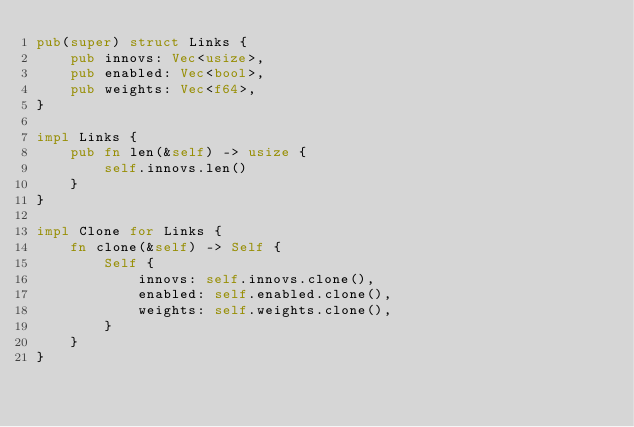<code> <loc_0><loc_0><loc_500><loc_500><_Rust_>pub(super) struct Links {
    pub innovs: Vec<usize>,
    pub enabled: Vec<bool>,
    pub weights: Vec<f64>,
}

impl Links {
    pub fn len(&self) -> usize {
        self.innovs.len()
    }
}

impl Clone for Links {
    fn clone(&self) -> Self {
        Self {
            innovs: self.innovs.clone(),
            enabled: self.enabled.clone(),
            weights: self.weights.clone(),
        }
    }
}
</code> 